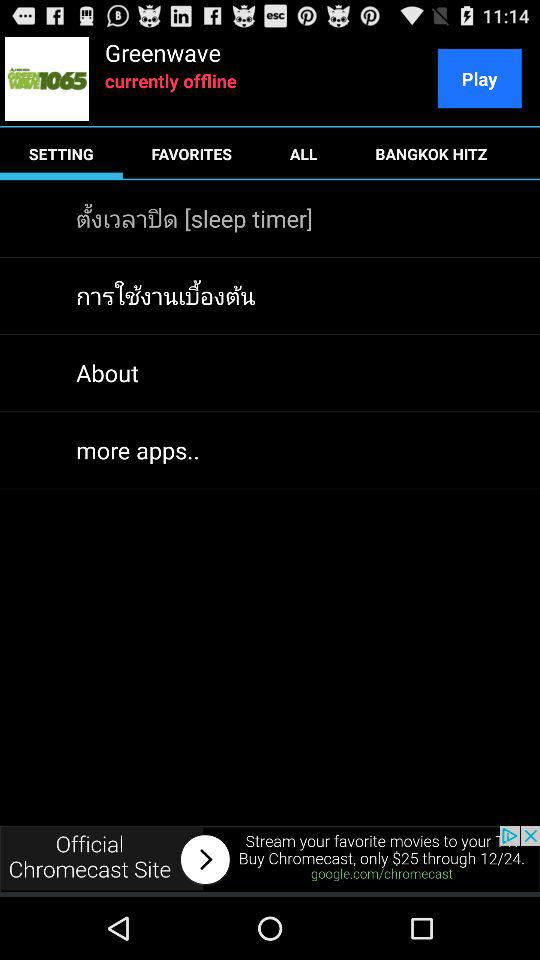Which tab is selected? The selected tab is "SETTING". 